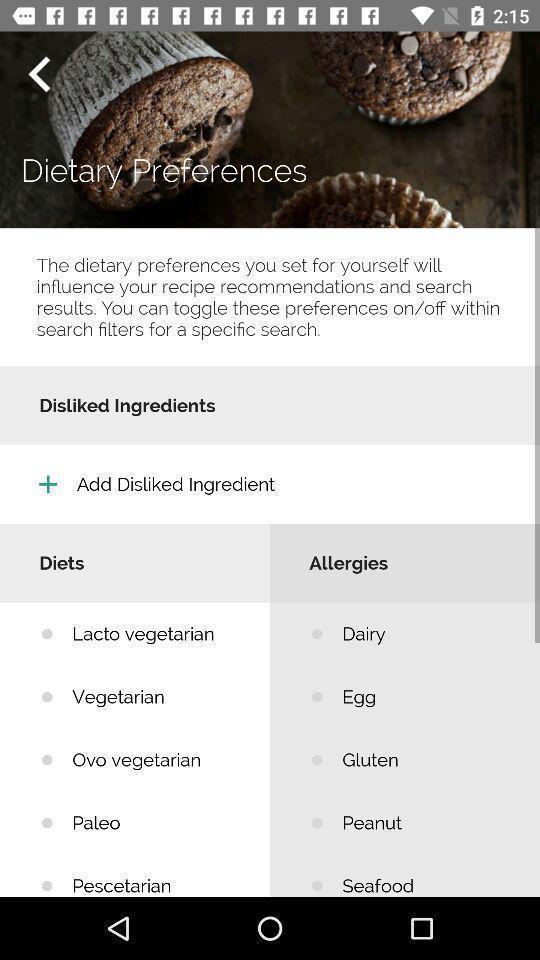What is the overall content of this screenshot? Page displaying list of diet plan. 